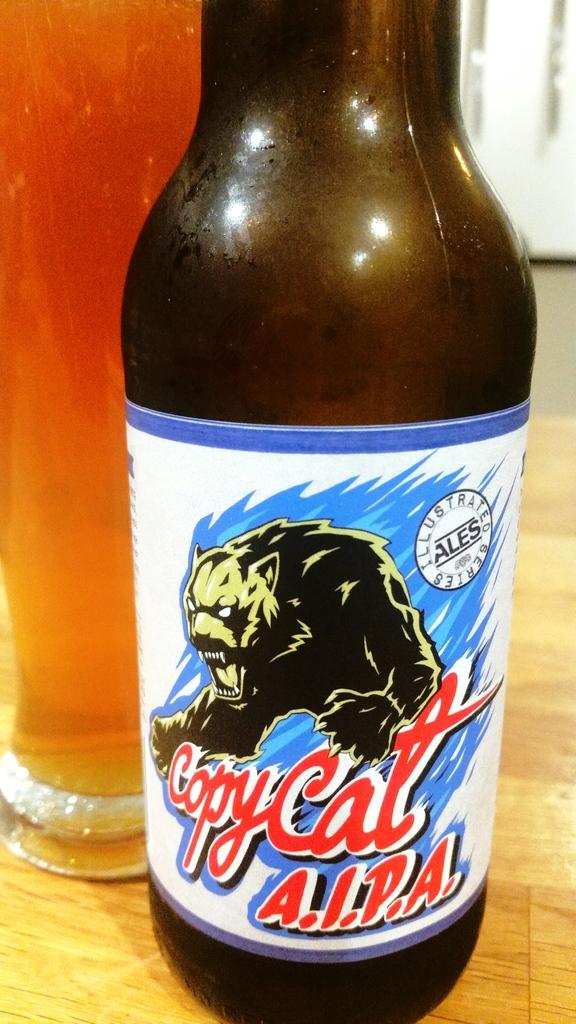Provide a one-sentence caption for the provided image. A close up shot of a beer bottle from the company Copy Cat AIPA. 